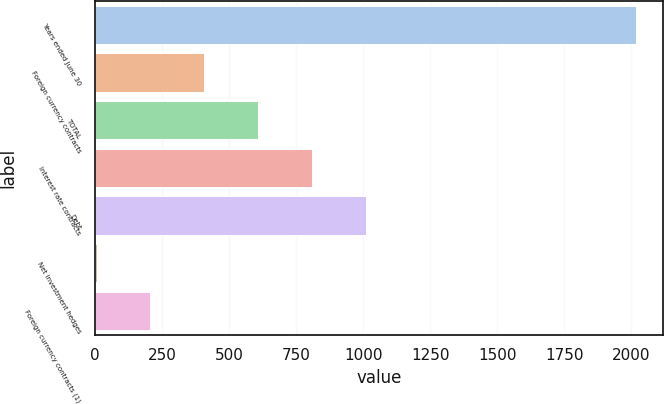<chart> <loc_0><loc_0><loc_500><loc_500><bar_chart><fcel>Years ended June 30<fcel>Foreign currency contracts<fcel>TOTAL<fcel>Interest rate contracts<fcel>Debt<fcel>Net investment hedges<fcel>Foreign currency contracts (1)<nl><fcel>2017<fcel>408.2<fcel>609.3<fcel>810.4<fcel>1011.5<fcel>6<fcel>207.1<nl></chart> 